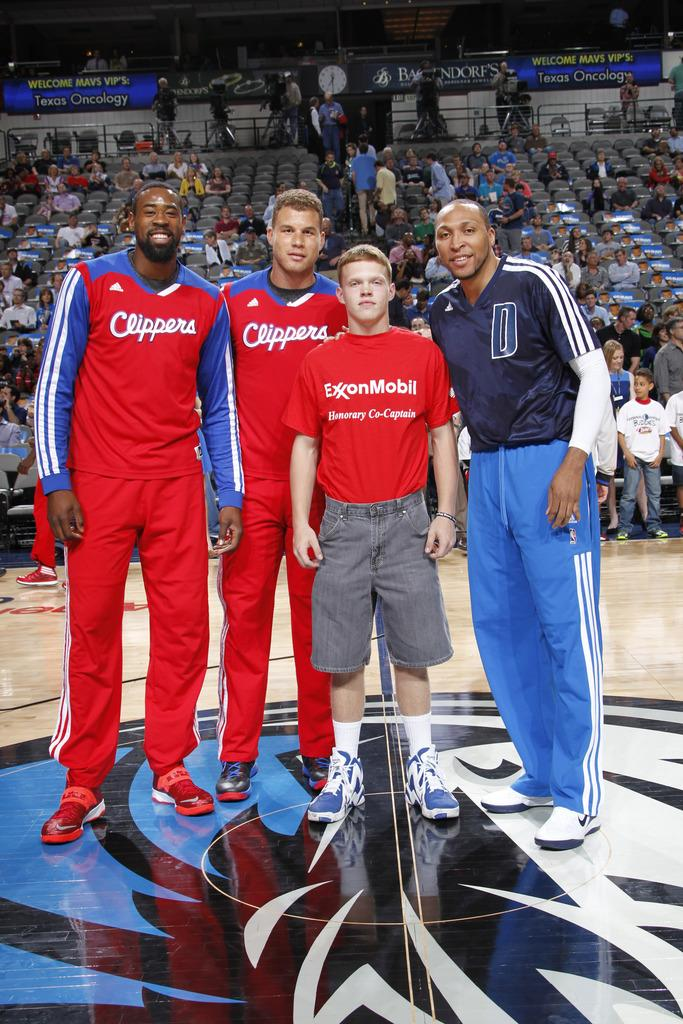<image>
Relay a brief, clear account of the picture shown. clippers players posing for photo with a exxonmobil honorary co-captain 